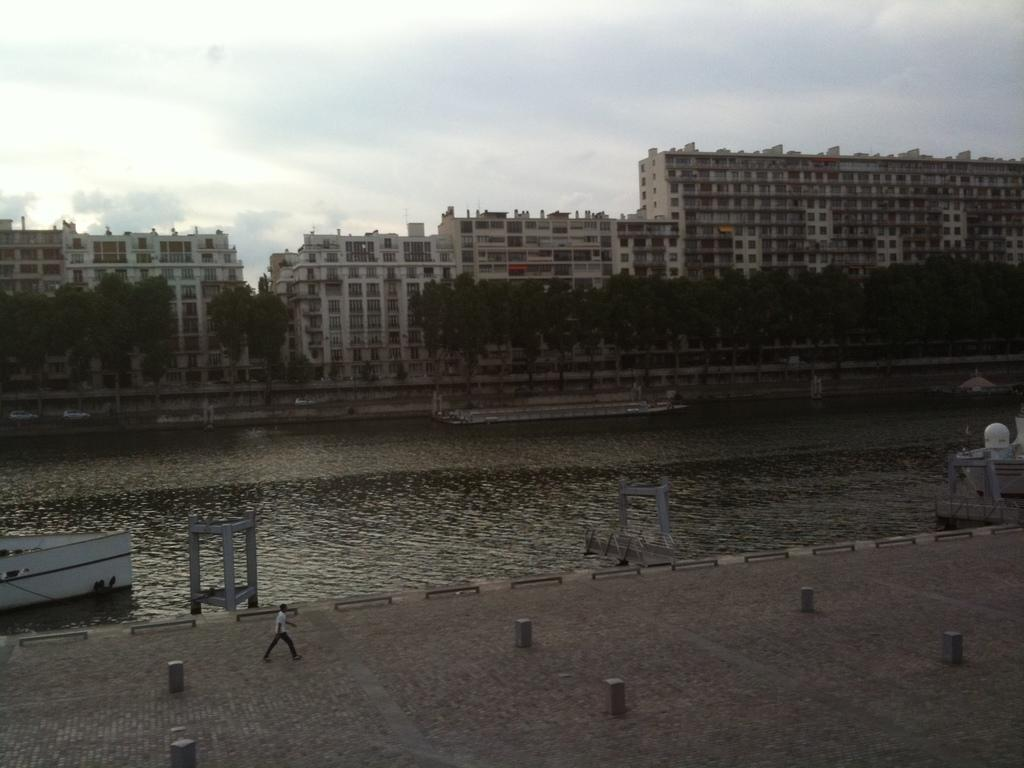What is on the water surface in the image? There are boats on the water surface in the image. What are the people in the image doing? People are walking on the road in the image. What type of structures can be seen in the image? There are buildings visible in the image. What type of vegetation is present in the image? Trees are present in the image. Can you tell me how many judges are walking on the road in the image? There is no judge present in the image; people are walking on the road. What type of worm can be seen crawling on the trees in the image? There is no worm present in the image; only trees are visible. 